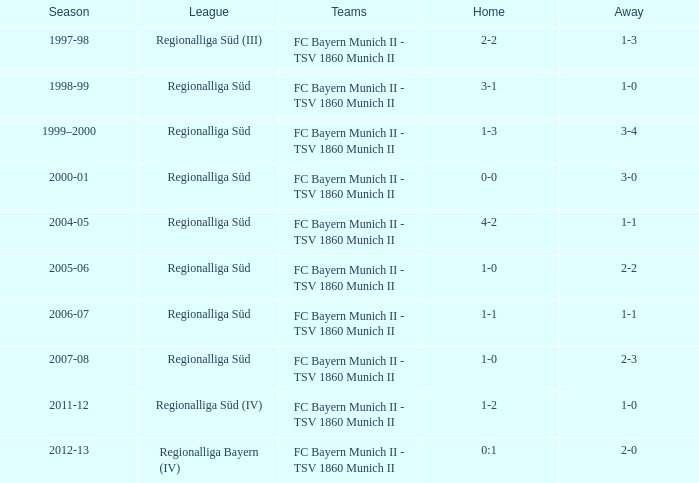What season features a regionalliga süd league, a 1-0 home, and a 2-3 away? 2007-08. 